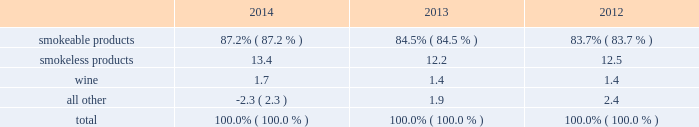Part i item 1 .
Business .
General development of business general : altria group , inc .
Is a holding company incorporated in the commonwealth of virginia in 1985 .
At december 31 , 2014 , altria group , inc . 2019s wholly-owned subsidiaries included philip morris usa inc .
( 201cpm usa 201d ) , which is engaged predominantly in the manufacture and sale of cigarettes in the united states ; john middleton co .
( 201cmiddleton 201d ) , which is engaged in the manufacture and sale of machine-made large cigars and pipe tobacco , and is a wholly- owned subsidiary of pm usa ; and ust llc ( 201cust 201d ) , which through its wholly-owned subsidiaries , including u.s .
Smokeless tobacco company llc ( 201cusstc 201d ) and ste .
Michelle wine estates ltd .
( 201cste .
Michelle 201d ) , is engaged in the manufacture and sale of smokeless tobacco products and wine .
Altria group , inc . 2019s other operating companies included nu mark llc ( 201cnu mark 201d ) , a wholly-owned subsidiary that is engaged in the manufacture and sale of innovative tobacco products , and philip morris capital corporation ( 201cpmcc 201d ) , a wholly-owned subsidiary that maintains a portfolio of finance assets , substantially all of which are leveraged leases .
Other altria group , inc .
Wholly-owned subsidiaries included altria group distribution company , which provides sales , distribution and consumer engagement services to certain altria group , inc .
Operating subsidiaries , and altria client services inc. , which provides various support services , such as legal , regulatory , finance , human resources and external affairs , to altria group , inc .
And its subsidiaries .
At december 31 , 2014 , altria group , inc .
Also held approximately 27% ( 27 % ) of the economic and voting interest of sabmiller plc ( 201csabmiller 201d ) , which altria group , inc .
Accounts for under the equity method of accounting .
Source of funds : because altria group , inc .
Is a holding company , its access to the operating cash flows of its wholly- owned subsidiaries consists of cash received from the payment of dividends and distributions , and the payment of interest on intercompany loans by its subsidiaries .
At december 31 , 2014 , altria group , inc . 2019s principal wholly-owned subsidiaries were not limited by long-term debt or other agreements in their ability to pay cash dividends or make other distributions with respect to their equity interests .
In addition , altria group , inc .
Receives cash dividends on its interest in sabmiller if and when sabmiller pays such dividends .
Financial information about segments altria group , inc . 2019s reportable segments are smokeable products , smokeless products and wine .
The financial services and the innovative tobacco products businesses are included in an all other category due to the continued reduction of the lease portfolio of pmcc and the relative financial contribution of altria group , inc . 2019s innovative tobacco products businesses to altria group , inc . 2019s consolidated results .
Altria group , inc . 2019s chief operating decision maker reviews operating companies income to evaluate the performance of , and allocate resources to , the segments .
Operating companies income for the segments is defined as operating income before amortization of intangibles and general corporate expenses .
Interest and other debt expense , net , and provision for income taxes are centrally managed at the corporate level and , accordingly , such items are not presented by segment since they are excluded from the measure of segment profitability reviewed by altria group , inc . 2019s chief operating decision maker .
Net revenues and operating companies income ( together with a reconciliation to earnings before income taxes ) attributable to each such segment for each of the last three years are set forth in note 15 .
Segment reporting to the consolidated financial statements in item 8 .
Financial statements and supplementary data of this annual report on form 10-k ( 201citem 8 201d ) .
Information about total assets by segment is not disclosed because such information is not reported to or used by altria group , inc . 2019s chief operating decision maker .
Segment goodwill and other intangible assets , net , are disclosed in note 4 .
Goodwill and other intangible assets , net to the consolidated financial statements in item 8 ( 201cnote 4 201d ) .
The accounting policies of the segments are the same as those described in note 2 .
Summary of significant accounting policies to the consolidated financial statements in item 8 ( 201cnote 2 201d ) .
The relative percentages of operating companies income ( loss ) attributable to each reportable segment and the all other category were as follows: .
For items affecting the comparability of the relative percentages of operating companies income ( loss ) attributable to each reportable segment , see note 15 .
Segment reporting to the consolidated financial statements in item 8 ( 201cnote 15 201d ) .
Narrative description of business portions of the information called for by this item are included in item 7 .
Management 2019s discussion and analysis of financial condition and results of operations - operating results by business segment of this annual report on form 10-k .
Tobacco space altria group , inc . 2019s tobacco operating companies include pm usa , usstc and other subsidiaries of ust , middleton and nu mark .
Altria group distribution company provides sales , distribution and consumer engagement services to altria group , inc . 2019s tobacco operating companies .
The products of altria group , inc . 2019s tobacco subsidiaries include smokeable tobacco products comprised of cigarettes manufactured and sold by pm usa and machine-made large altria_mdc_2014form10k_nolinks_crops.pdf 3 2/25/15 5:56 pm .
What is the percent change in the relative percentages of operating companies income ( loss ) attributable to smokeable products from 2013 to 2014? 
Computations: (87.2% - 84.5%)
Answer: 0.027. 